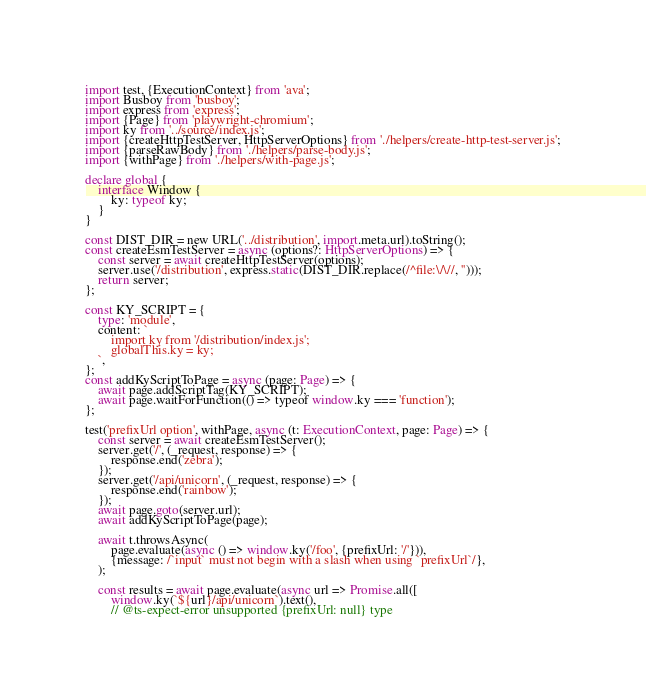<code> <loc_0><loc_0><loc_500><loc_500><_TypeScript_>import test, {ExecutionContext} from 'ava';
import Busboy from 'busboy';
import express from 'express';
import {Page} from 'playwright-chromium';
import ky from '../source/index.js';
import {createHttpTestServer, HttpServerOptions} from './helpers/create-http-test-server.js';
import {parseRawBody} from './helpers/parse-body.js';
import {withPage} from './helpers/with-page.js';

declare global {
	interface Window {
		ky: typeof ky;
	}
}

const DIST_DIR = new URL('../distribution', import.meta.url).toString();
const createEsmTestServer = async (options?: HttpServerOptions) => {
	const server = await createHttpTestServer(options);
	server.use('/distribution', express.static(DIST_DIR.replace(/^file:\/\//, '')));
	return server;
};

const KY_SCRIPT = {
	type: 'module',
	content: `
		import ky from '/distribution/index.js';
		globalThis.ky = ky;
	`,
};
const addKyScriptToPage = async (page: Page) => {
	await page.addScriptTag(KY_SCRIPT);
	await page.waitForFunction(() => typeof window.ky === 'function');
};

test('prefixUrl option', withPage, async (t: ExecutionContext, page: Page) => {
	const server = await createEsmTestServer();
	server.get('/', (_request, response) => {
		response.end('zebra');
	});
	server.get('/api/unicorn', (_request, response) => {
		response.end('rainbow');
	});
	await page.goto(server.url);
	await addKyScriptToPage(page);

	await t.throwsAsync(
		page.evaluate(async () => window.ky('/foo', {prefixUrl: '/'})),
		{message: /`input` must not begin with a slash when using `prefixUrl`/},
	);

	const results = await page.evaluate(async url => Promise.all([
		window.ky(`${url}/api/unicorn`).text(),
		// @ts-expect-error unsupported {prefixUrl: null} type</code> 